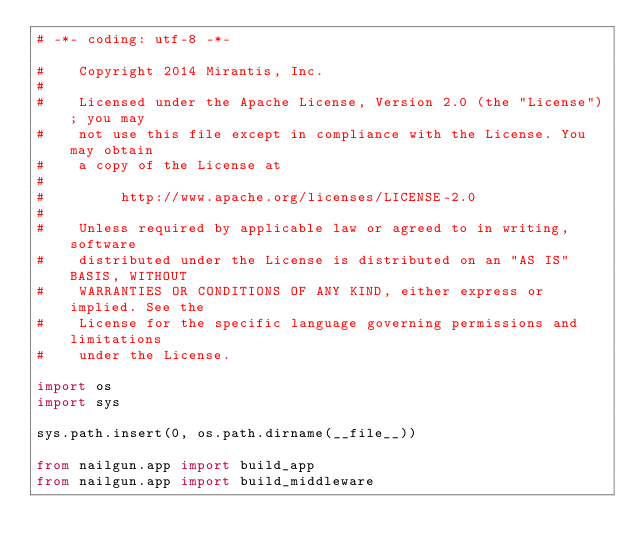<code> <loc_0><loc_0><loc_500><loc_500><_Python_># -*- coding: utf-8 -*-

#    Copyright 2014 Mirantis, Inc.
#
#    Licensed under the Apache License, Version 2.0 (the "License"); you may
#    not use this file except in compliance with the License. You may obtain
#    a copy of the License at
#
#         http://www.apache.org/licenses/LICENSE-2.0
#
#    Unless required by applicable law or agreed to in writing, software
#    distributed under the License is distributed on an "AS IS" BASIS, WITHOUT
#    WARRANTIES OR CONDITIONS OF ANY KIND, either express or implied. See the
#    License for the specific language governing permissions and limitations
#    under the License.

import os
import sys

sys.path.insert(0, os.path.dirname(__file__))

from nailgun.app import build_app
from nailgun.app import build_middleware

</code> 